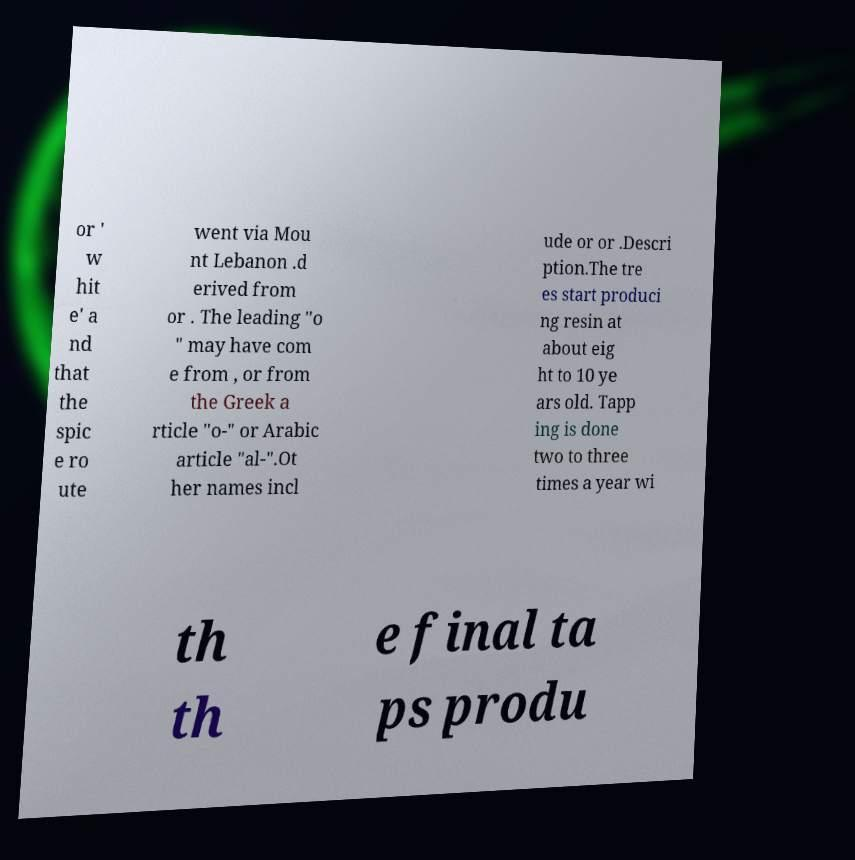There's text embedded in this image that I need extracted. Can you transcribe it verbatim? or ' w hit e' a nd that the spic e ro ute went via Mou nt Lebanon .d erived from or . The leading "o " may have com e from , or from the Greek a rticle "o-" or Arabic article "al-".Ot her names incl ude or or .Descri ption.The tre es start produci ng resin at about eig ht to 10 ye ars old. Tapp ing is done two to three times a year wi th th e final ta ps produ 